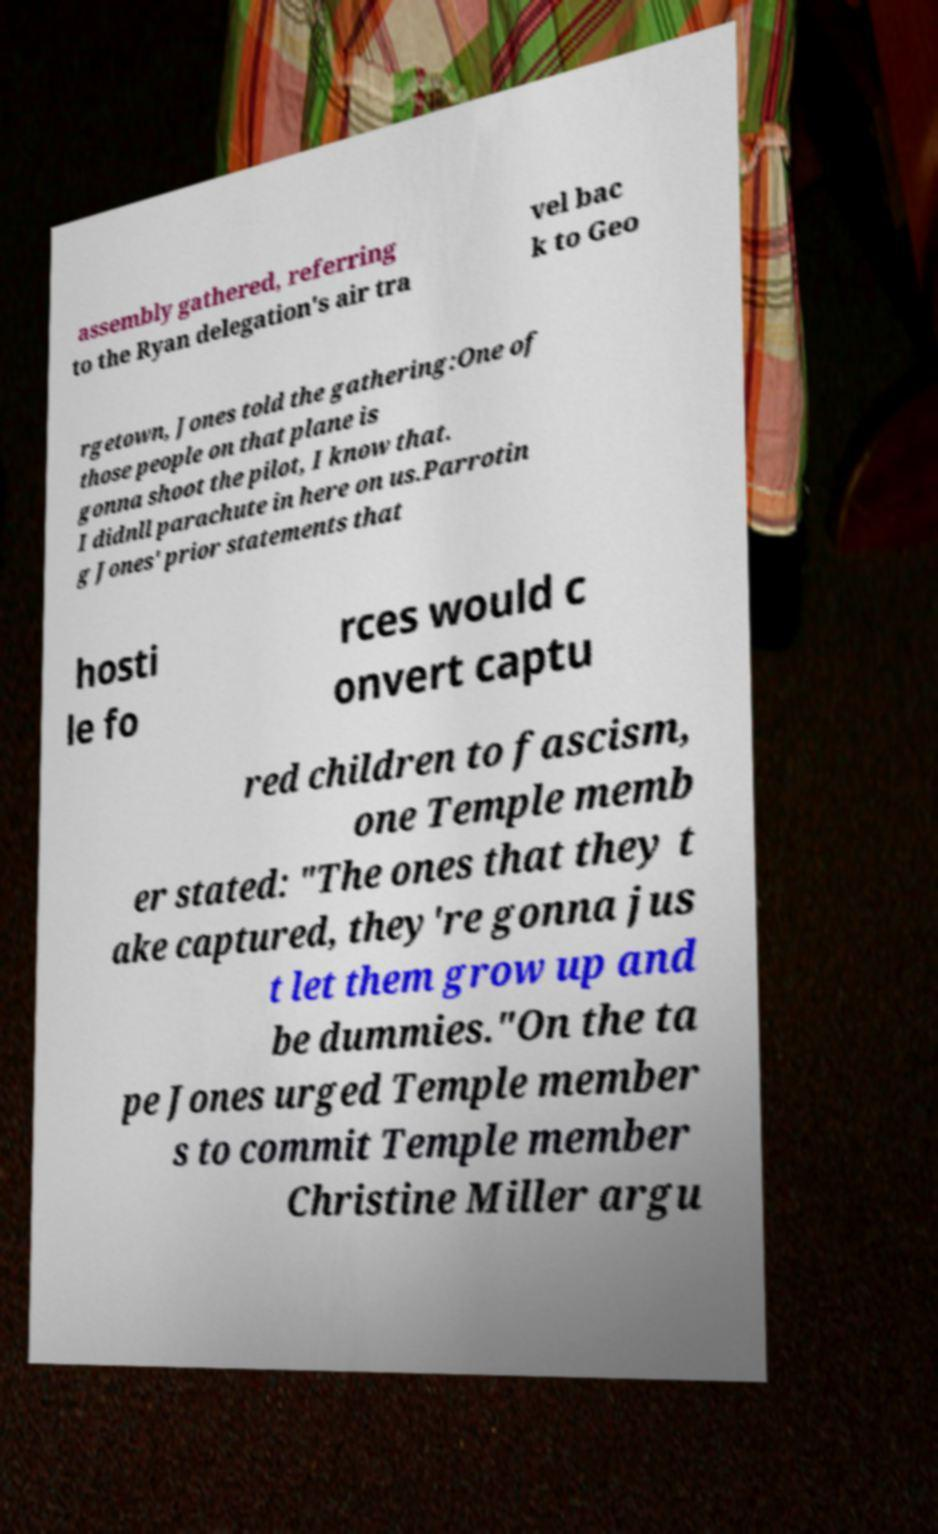Can you read and provide the text displayed in the image?This photo seems to have some interesting text. Can you extract and type it out for me? assembly gathered, referring to the Ryan delegation's air tra vel bac k to Geo rgetown, Jones told the gathering:One of those people on that plane is gonna shoot the pilot, I know that. I didnll parachute in here on us.Parrotin g Jones' prior statements that hosti le fo rces would c onvert captu red children to fascism, one Temple memb er stated: "The ones that they t ake captured, they're gonna jus t let them grow up and be dummies."On the ta pe Jones urged Temple member s to commit Temple member Christine Miller argu 